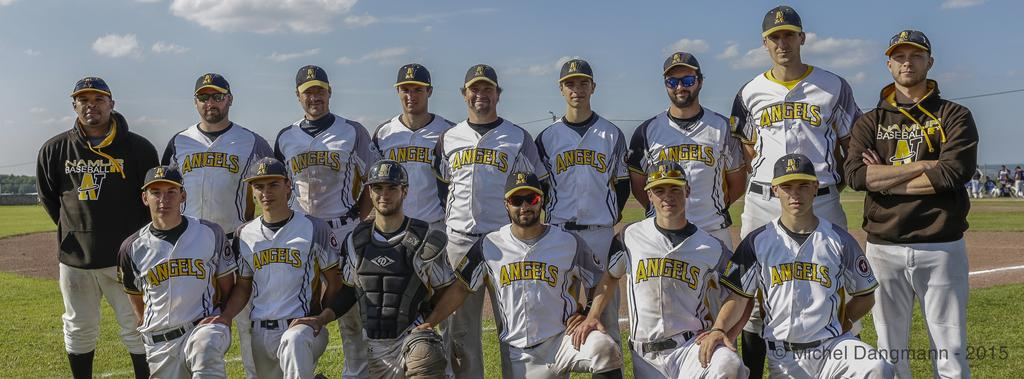<image>
Provide a brief description of the given image. Members of the Angels stand together on the field. 